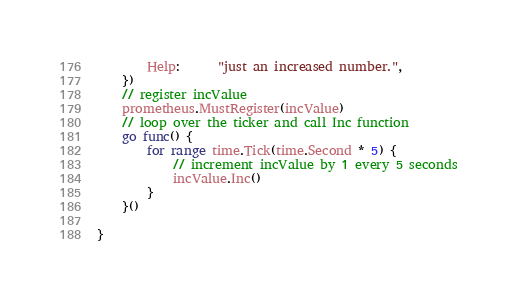Convert code to text. <code><loc_0><loc_0><loc_500><loc_500><_Go_>		Help:      "just an increased number.",
	})
	// register incValue
	prometheus.MustRegister(incValue)
	// loop over the ticker and call Inc function
	go func() {
		for range time.Tick(time.Second * 5) {
			// increment incValue by 1 every 5 seconds
			incValue.Inc()
		}
	}()

}
</code> 